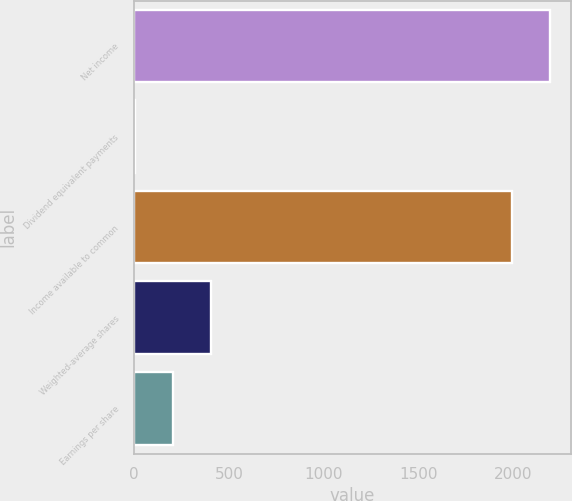<chart> <loc_0><loc_0><loc_500><loc_500><bar_chart><fcel>Net income<fcel>Dividend equivalent payments<fcel>Income available to common<fcel>Weighted-average shares<fcel>Earnings per share<nl><fcel>2195.6<fcel>4<fcel>1996<fcel>403.2<fcel>203.6<nl></chart> 